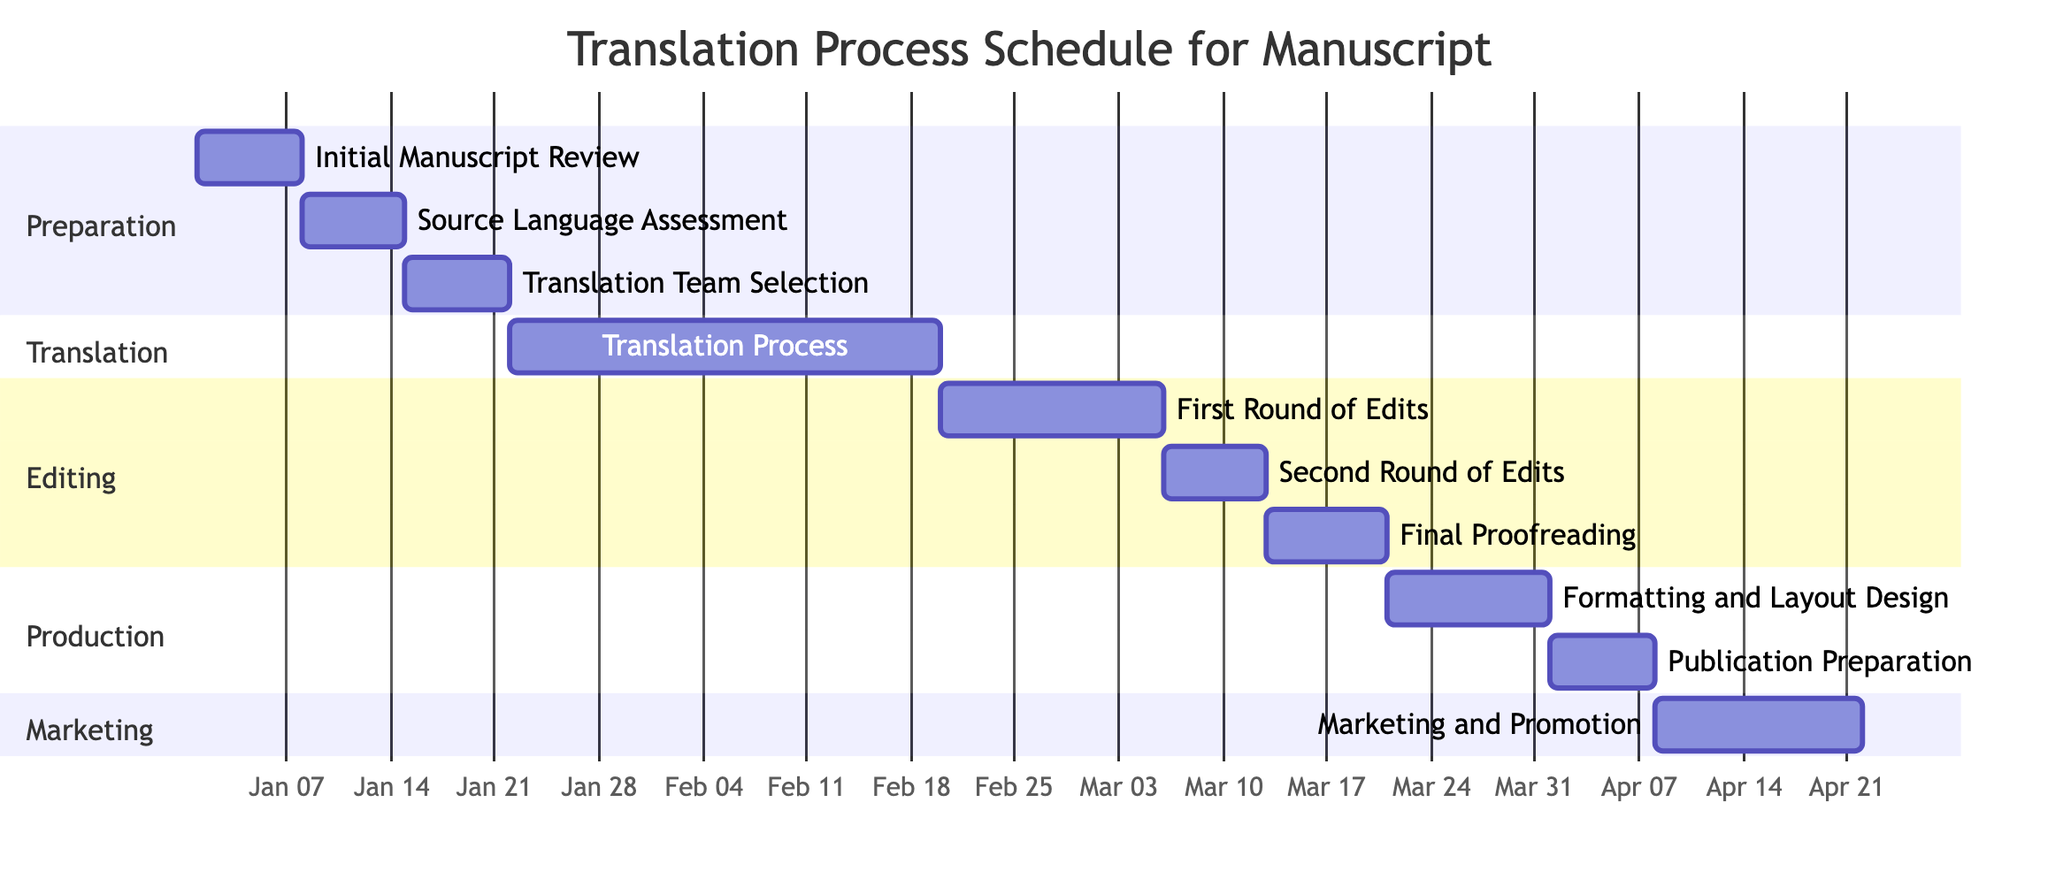What is the duration of the Translation Process? The Translation Process starts on January 22, 2024, and ends on February 19, 2024. To find the duration, we calculate the difference between these dates, which is 29 days.
Answer: 29 days What task follows the Source Language Assessment? After the Source Language Assessment ends on January 14, 2024, the next task is Translation Team Selection, which starts on January 15, 2024.
Answer: Translation Team Selection How many rounds of edits are scheduled in the process? The diagram lists two rounds of edits: First Round of Edits and Second Round of Edits. Therefore, the total number of rounds is two.
Answer: 2 What is the total duration for the Editing section? The total duration of the Editing section consists of three tasks: First Round of Edits (15 days), Second Round of Edits (7 days), and Final Proofreading (8 days). Adding these gives 15 + 7 + 8 = 30 days for the Editing section.
Answer: 30 days Which task begins immediately after the First Round of Edits? The task that follows immediately after the First Round of Edits, which ends on March 5, 2024, is the Second Round of Edits, starting on March 6, 2024.
Answer: Second Round of Edits What is the end date of the Publication Preparation task? The Publication Preparation task starts on April 1, 2024, and lasts for 7 days, ending on April 7, 2024.
Answer: April 7, 2024 Which section has the task with the longest duration? The Translation section includes the Translation Process task which lasts for 29 days, which is the longest duration compared to other tasks in their respective sections.
Answer: Translation section What task is scheduled immediately before Marketing and Promotion? The task that comes right before Marketing and Promotion, which starts on April 8, 2024, is Publication Preparation, ending on April 7, 2024.
Answer: Publication Preparation 